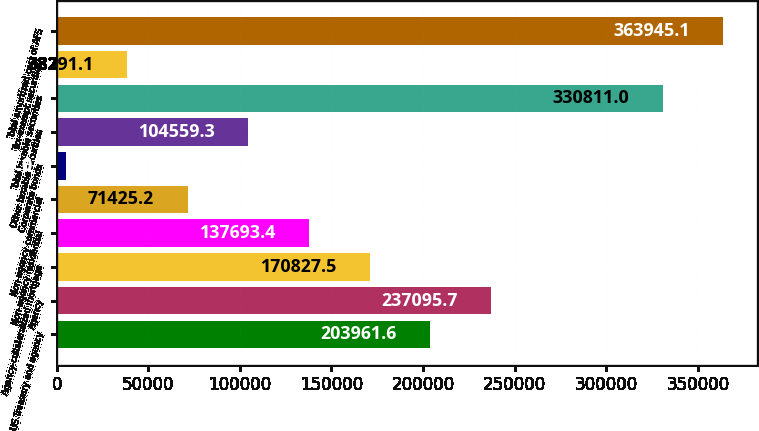Convert chart. <chart><loc_0><loc_0><loc_500><loc_500><bar_chart><fcel>US Treasury and agency<fcel>Agency<fcel>Agency-collateralized mortgage<fcel>Non-agency residential<fcel>Non-agency commercial<fcel>Corporate bonds<fcel>Other taxable securities<fcel>Total taxable securities<fcel>Tax-exempt securities<fcel>Total amortized cost of AFS<nl><fcel>203962<fcel>237096<fcel>170828<fcel>137693<fcel>71425.2<fcel>5157<fcel>104559<fcel>330811<fcel>38291.1<fcel>363945<nl></chart> 